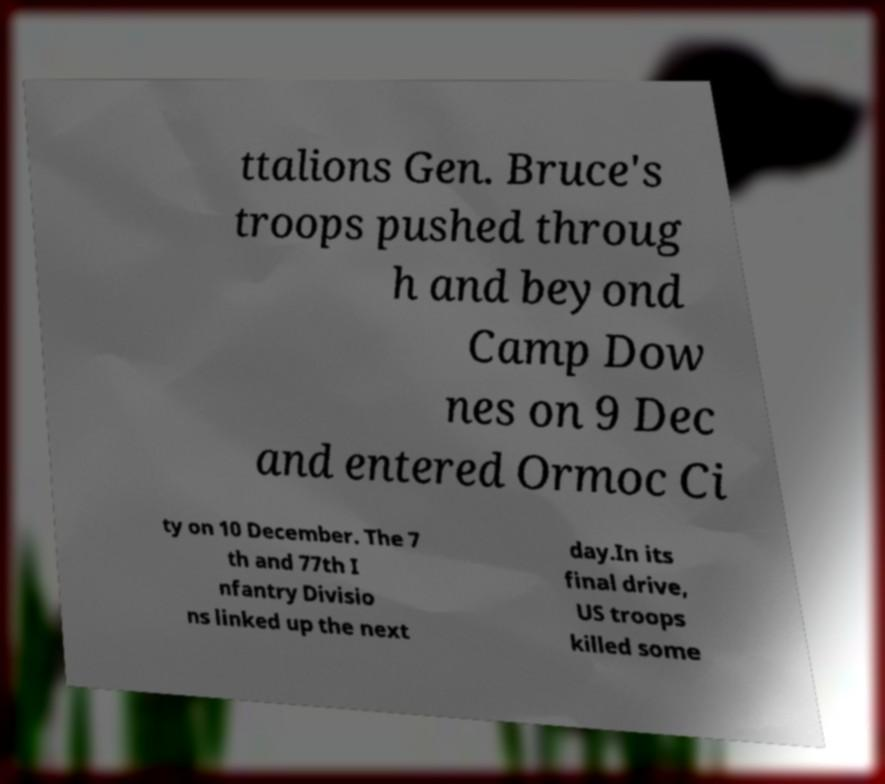Could you assist in decoding the text presented in this image and type it out clearly? ttalions Gen. Bruce's troops pushed throug h and beyond Camp Dow nes on 9 Dec and entered Ormoc Ci ty on 10 December. The 7 th and 77th I nfantry Divisio ns linked up the next day.In its final drive, US troops killed some 